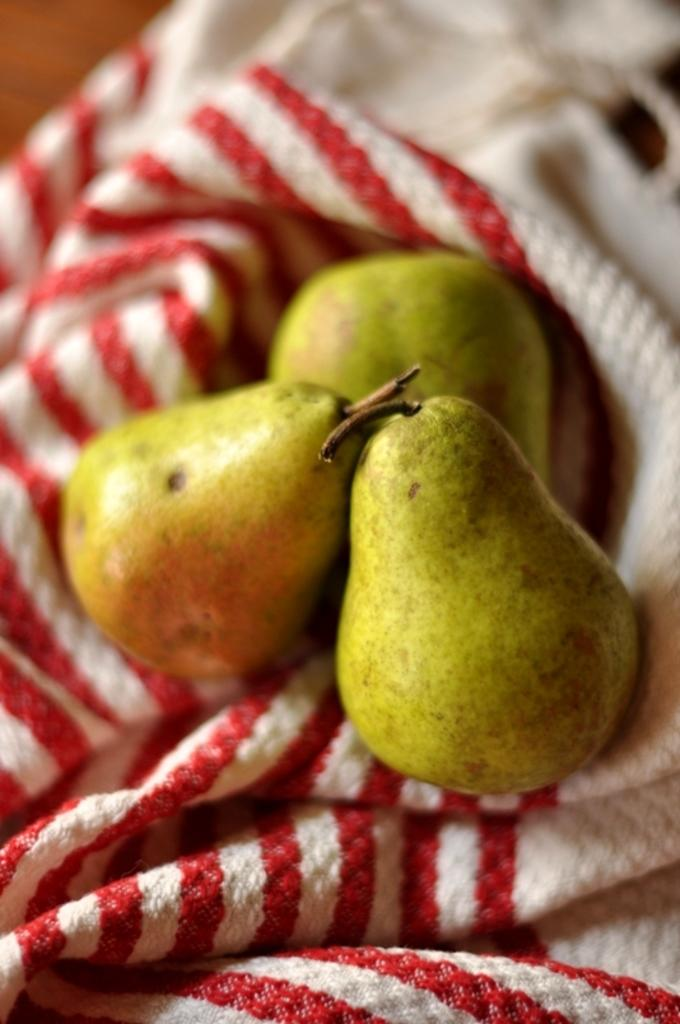What type of fruit is present in the image? There are avocados in the image. How are the avocados arranged or placed in the image? The avocados are placed on a red and white colored cloth. Can you describe the top part of the image? The top of the image is blurred. What type of tray is used to hold the avocados in the image? There is no tray present in the image; the avocados are placed on a red and white colored cloth. How does the concept of friction apply to the avocados in the image? The concept of friction does not apply to the avocados in the image, as they are stationary on the cloth. 